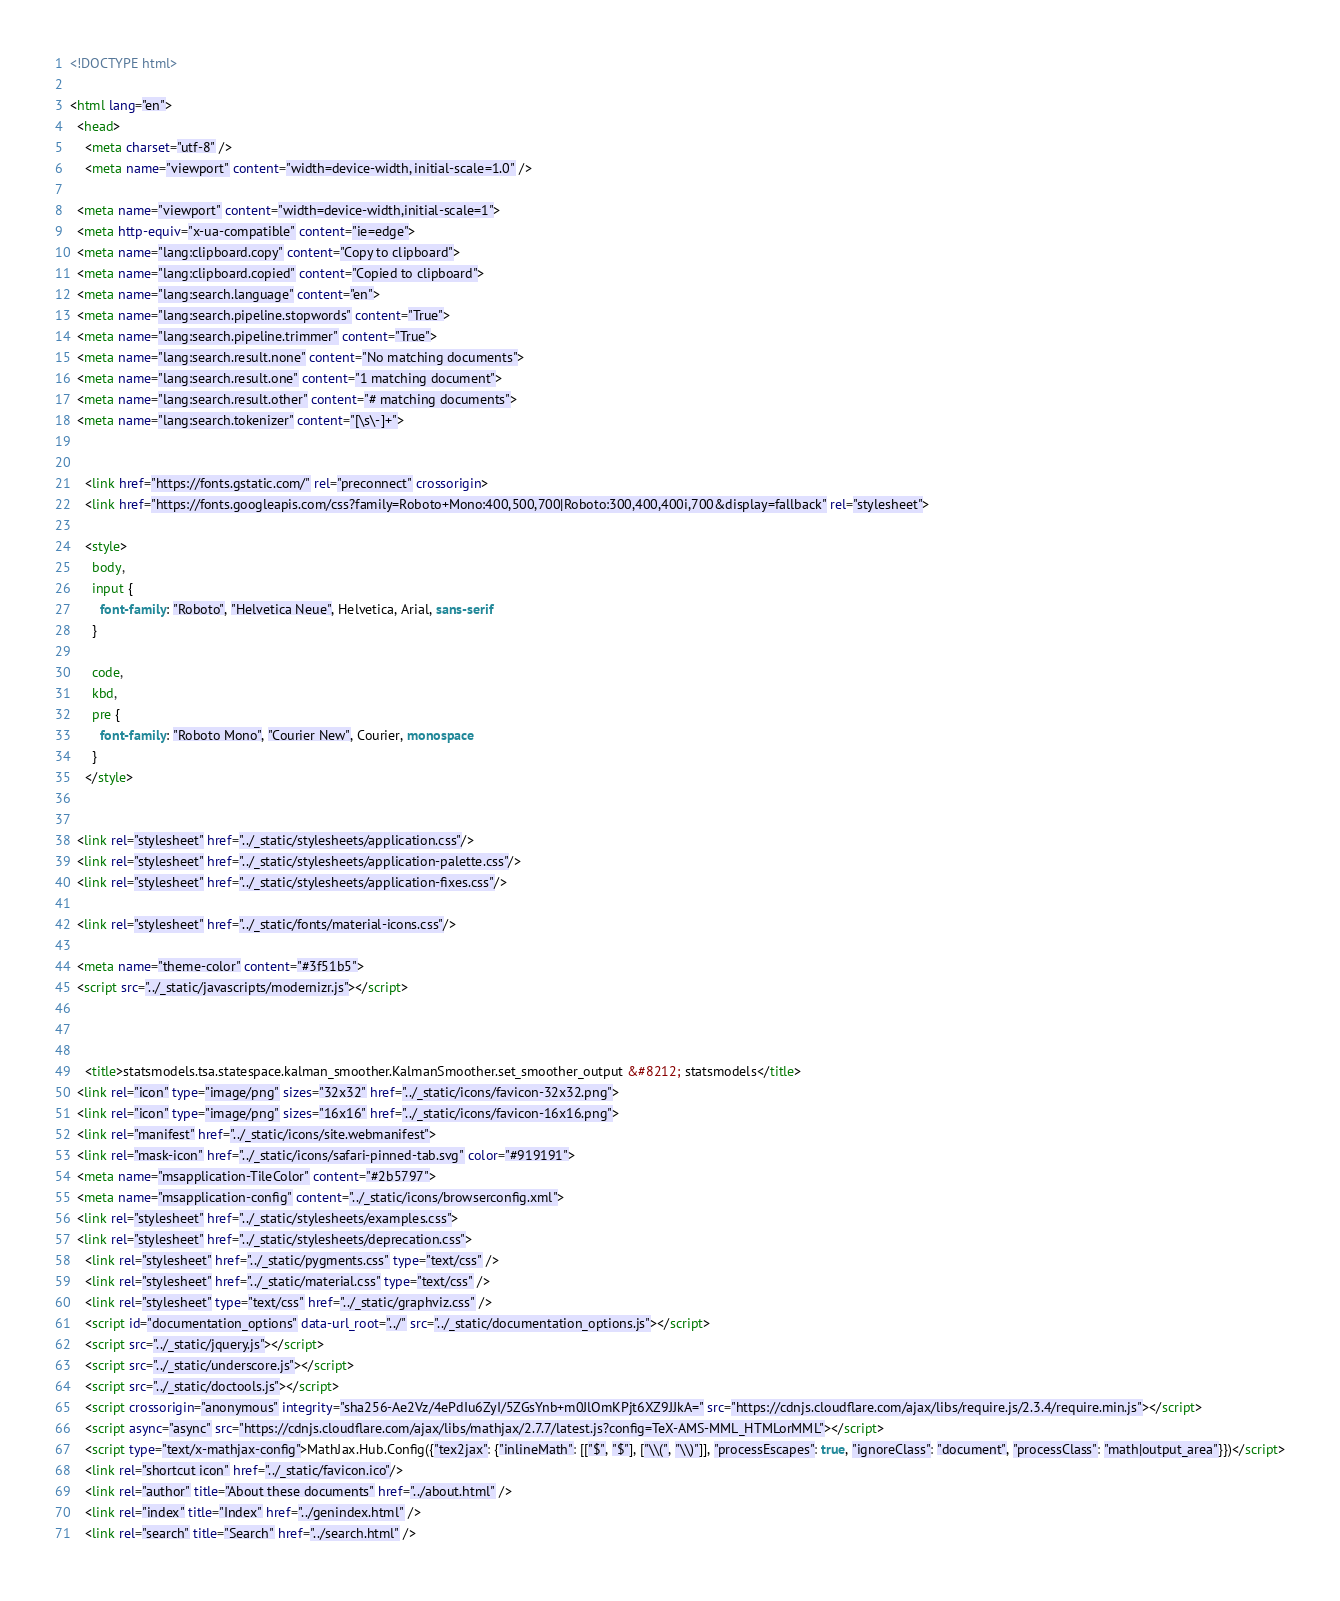<code> <loc_0><loc_0><loc_500><loc_500><_HTML_>

<!DOCTYPE html>

<html lang="en">
  <head>
    <meta charset="utf-8" />
    <meta name="viewport" content="width=device-width, initial-scale=1.0" />
  
  <meta name="viewport" content="width=device-width,initial-scale=1">
  <meta http-equiv="x-ua-compatible" content="ie=edge">
  <meta name="lang:clipboard.copy" content="Copy to clipboard">
  <meta name="lang:clipboard.copied" content="Copied to clipboard">
  <meta name="lang:search.language" content="en">
  <meta name="lang:search.pipeline.stopwords" content="True">
  <meta name="lang:search.pipeline.trimmer" content="True">
  <meta name="lang:search.result.none" content="No matching documents">
  <meta name="lang:search.result.one" content="1 matching document">
  <meta name="lang:search.result.other" content="# matching documents">
  <meta name="lang:search.tokenizer" content="[\s\-]+">

  
    <link href="https://fonts.gstatic.com/" rel="preconnect" crossorigin>
    <link href="https://fonts.googleapis.com/css?family=Roboto+Mono:400,500,700|Roboto:300,400,400i,700&display=fallback" rel="stylesheet">

    <style>
      body,
      input {
        font-family: "Roboto", "Helvetica Neue", Helvetica, Arial, sans-serif
      }

      code,
      kbd,
      pre {
        font-family: "Roboto Mono", "Courier New", Courier, monospace
      }
    </style>
  

  <link rel="stylesheet" href="../_static/stylesheets/application.css"/>
  <link rel="stylesheet" href="../_static/stylesheets/application-palette.css"/>
  <link rel="stylesheet" href="../_static/stylesheets/application-fixes.css"/>
  
  <link rel="stylesheet" href="../_static/fonts/material-icons.css"/>
  
  <meta name="theme-color" content="#3f51b5">
  <script src="../_static/javascripts/modernizr.js"></script>
  
  
  
    <title>statsmodels.tsa.statespace.kalman_smoother.KalmanSmoother.set_smoother_output &#8212; statsmodels</title>
  <link rel="icon" type="image/png" sizes="32x32" href="../_static/icons/favicon-32x32.png">
  <link rel="icon" type="image/png" sizes="16x16" href="../_static/icons/favicon-16x16.png">
  <link rel="manifest" href="../_static/icons/site.webmanifest">
  <link rel="mask-icon" href="../_static/icons/safari-pinned-tab.svg" color="#919191">
  <meta name="msapplication-TileColor" content="#2b5797">
  <meta name="msapplication-config" content="../_static/icons/browserconfig.xml">
  <link rel="stylesheet" href="../_static/stylesheets/examples.css">
  <link rel="stylesheet" href="../_static/stylesheets/deprecation.css">
    <link rel="stylesheet" href="../_static/pygments.css" type="text/css" />
    <link rel="stylesheet" href="../_static/material.css" type="text/css" />
    <link rel="stylesheet" type="text/css" href="../_static/graphviz.css" />
    <script id="documentation_options" data-url_root="../" src="../_static/documentation_options.js"></script>
    <script src="../_static/jquery.js"></script>
    <script src="../_static/underscore.js"></script>
    <script src="../_static/doctools.js"></script>
    <script crossorigin="anonymous" integrity="sha256-Ae2Vz/4ePdIu6ZyI/5ZGsYnb+m0JlOmKPjt6XZ9JJkA=" src="https://cdnjs.cloudflare.com/ajax/libs/require.js/2.3.4/require.min.js"></script>
    <script async="async" src="https://cdnjs.cloudflare.com/ajax/libs/mathjax/2.7.7/latest.js?config=TeX-AMS-MML_HTMLorMML"></script>
    <script type="text/x-mathjax-config">MathJax.Hub.Config({"tex2jax": {"inlineMath": [["$", "$"], ["\\(", "\\)"]], "processEscapes": true, "ignoreClass": "document", "processClass": "math|output_area"}})</script>
    <link rel="shortcut icon" href="../_static/favicon.ico"/>
    <link rel="author" title="About these documents" href="../about.html" />
    <link rel="index" title="Index" href="../genindex.html" />
    <link rel="search" title="Search" href="../search.html" /></code> 